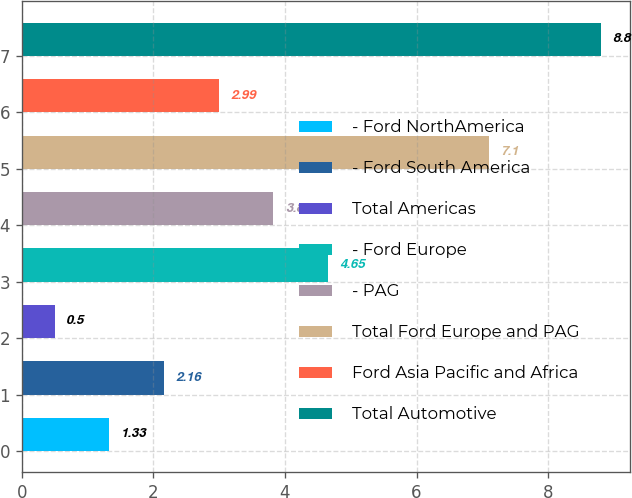Convert chart. <chart><loc_0><loc_0><loc_500><loc_500><bar_chart><fcel>- Ford NorthAmerica<fcel>- Ford South America<fcel>Total Americas<fcel>- Ford Europe<fcel>- PAG<fcel>Total Ford Europe and PAG<fcel>Ford Asia Pacific and Africa<fcel>Total Automotive<nl><fcel>1.33<fcel>2.16<fcel>0.5<fcel>4.65<fcel>3.82<fcel>7.1<fcel>2.99<fcel>8.8<nl></chart> 